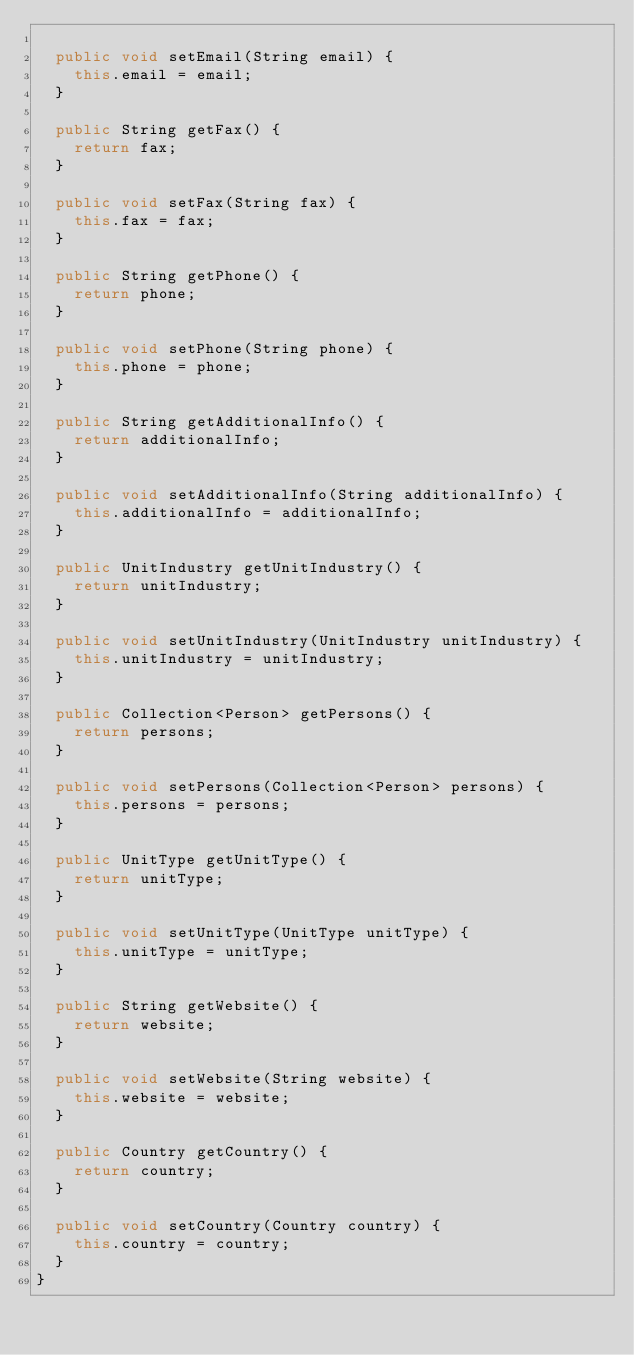<code> <loc_0><loc_0><loc_500><loc_500><_Java_>
  public void setEmail(String email) {
    this.email = email;
  }

  public String getFax() {
    return fax;
  }

  public void setFax(String fax) {
    this.fax = fax;
  }

  public String getPhone() {
    return phone;
  }

  public void setPhone(String phone) {
    this.phone = phone;
  }

  public String getAdditionalInfo() {
    return additionalInfo;
  }

  public void setAdditionalInfo(String additionalInfo) {
    this.additionalInfo = additionalInfo;
  }

  public UnitIndustry getUnitIndustry() {
    return unitIndustry;
  }

  public void setUnitIndustry(UnitIndustry unitIndustry) {
    this.unitIndustry = unitIndustry;
  }

  public Collection<Person> getPersons() {
    return persons;
  }

  public void setPersons(Collection<Person> persons) {
    this.persons = persons;
  }

  public UnitType getUnitType() {
    return unitType;
  }

  public void setUnitType(UnitType unitType) {
    this.unitType = unitType;
  }

  public String getWebsite() {
    return website;
  }

  public void setWebsite(String website) {
    this.website = website;
  }

  public Country getCountry() {
    return country;
  }

  public void setCountry(Country country) {
    this.country = country;
  }
}
</code> 